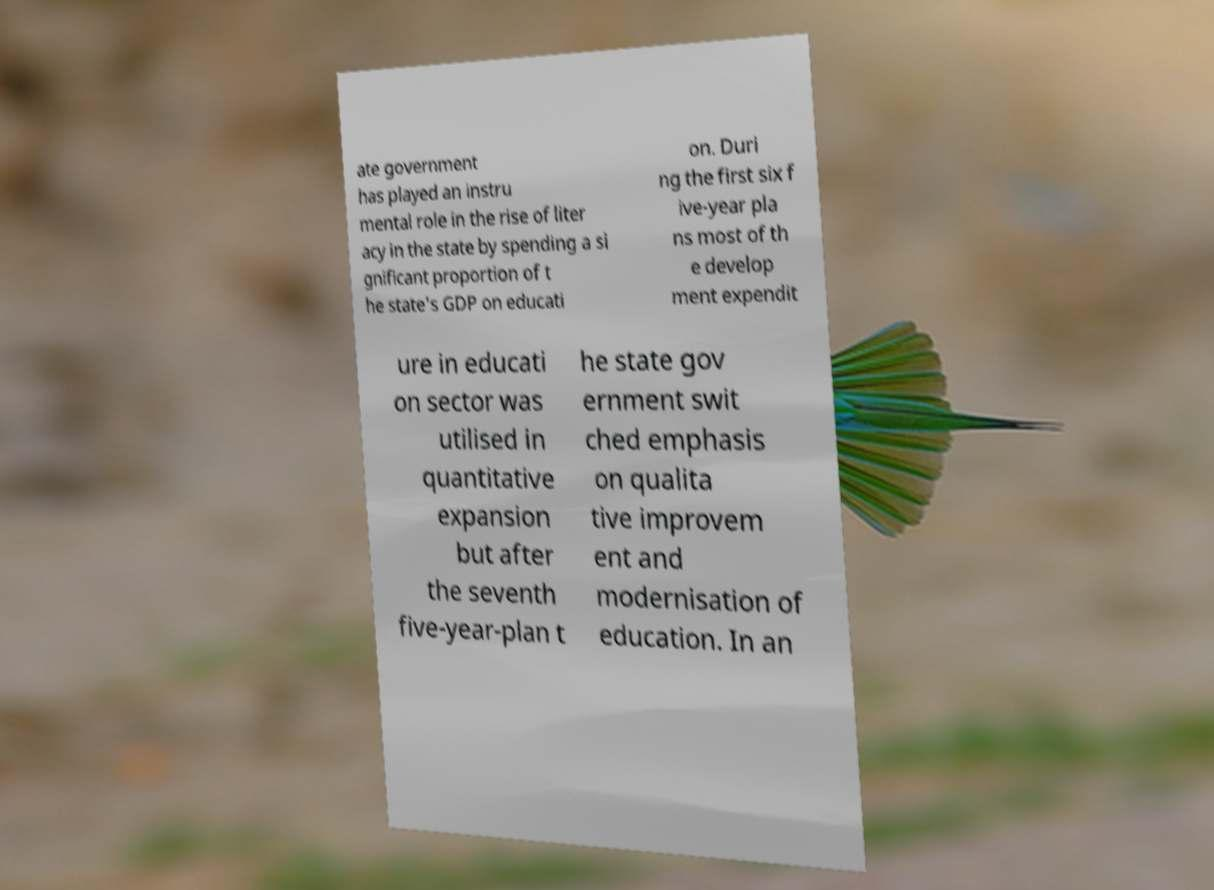Please read and relay the text visible in this image. What does it say? ate government has played an instru mental role in the rise of liter acy in the state by spending a si gnificant proportion of t he state's GDP on educati on. Duri ng the first six f ive-year pla ns most of th e develop ment expendit ure in educati on sector was utilised in quantitative expansion but after the seventh five-year-plan t he state gov ernment swit ched emphasis on qualita tive improvem ent and modernisation of education. In an 